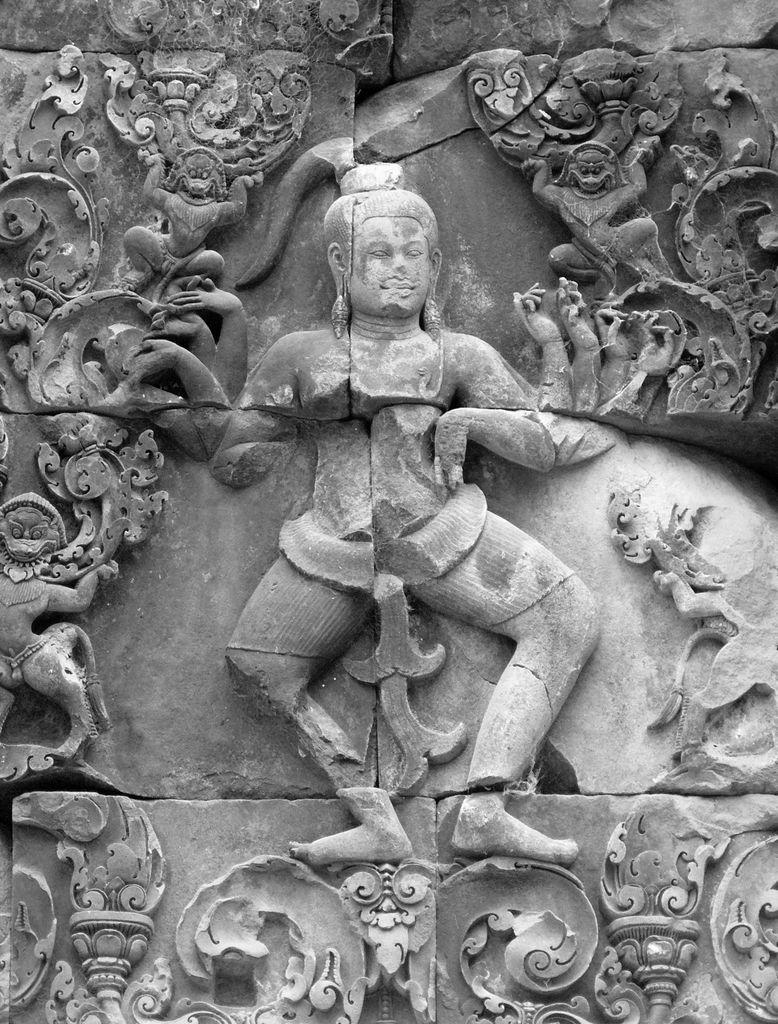What type of art is present in the image? There are sculptures in the image. Can you describe the color scheme of the sculptures? The sculptures are white and grey in color. What type of crayon is used to color the sticks in the image? There are no sticks or crayons present in the image; it features sculptures that are white and grey in color. 